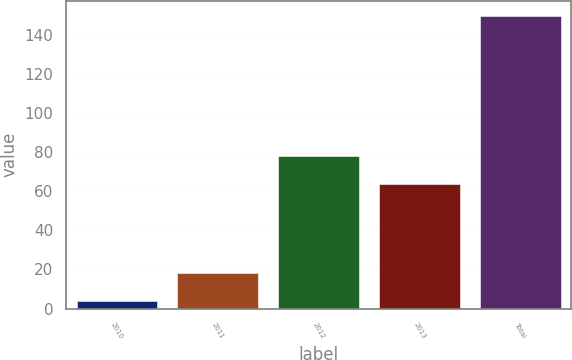Convert chart. <chart><loc_0><loc_0><loc_500><loc_500><bar_chart><fcel>2010<fcel>2011<fcel>2012<fcel>2013<fcel>Total<nl><fcel>3.8<fcel>18.42<fcel>78.32<fcel>63.7<fcel>150<nl></chart> 